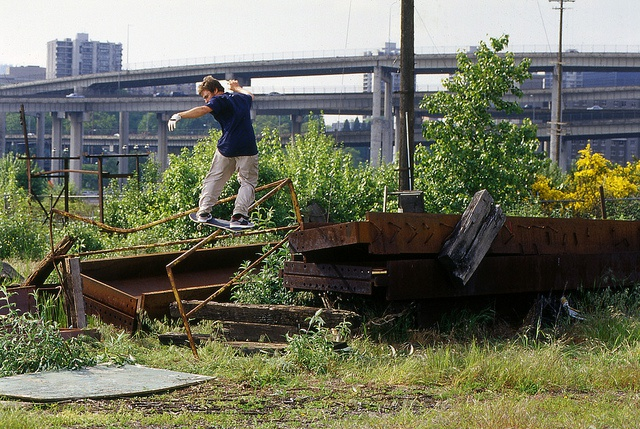Describe the objects in this image and their specific colors. I can see people in white, black, gray, and darkgray tones, skateboard in white, black, gray, lightgray, and darkgray tones, car in white, navy, gray, and darkblue tones, car in white, gray, darkgray, and lavender tones, and car in white, gray, darkgray, and blue tones in this image. 